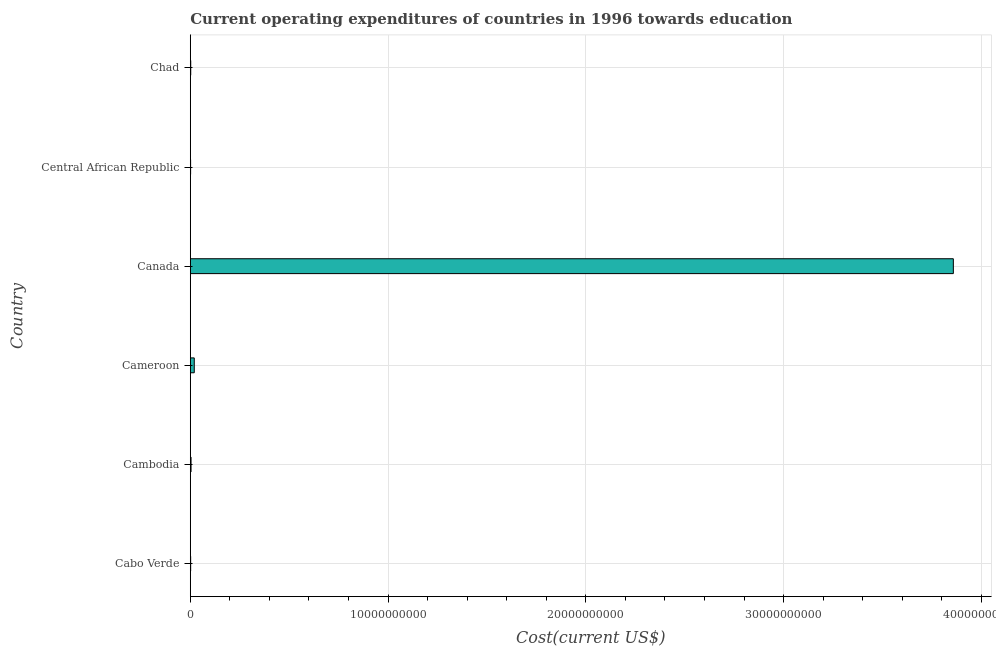What is the title of the graph?
Your answer should be compact. Current operating expenditures of countries in 1996 towards education. What is the label or title of the X-axis?
Keep it short and to the point. Cost(current US$). What is the label or title of the Y-axis?
Offer a terse response. Country. What is the education expenditure in Cameroon?
Make the answer very short. 2.01e+08. Across all countries, what is the maximum education expenditure?
Provide a succinct answer. 3.86e+1. Across all countries, what is the minimum education expenditure?
Give a very brief answer. 1.58e+07. In which country was the education expenditure maximum?
Provide a short and direct response. Canada. In which country was the education expenditure minimum?
Make the answer very short. Central African Republic. What is the sum of the education expenditure?
Give a very brief answer. 3.89e+1. What is the difference between the education expenditure in Cabo Verde and Central African Republic?
Your answer should be compact. 2.34e+06. What is the average education expenditure per country?
Your answer should be compact. 6.48e+09. What is the median education expenditure?
Ensure brevity in your answer.  3.03e+07. In how many countries, is the education expenditure greater than 20000000000 US$?
Your answer should be very brief. 1. What is the ratio of the education expenditure in Cambodia to that in Central African Republic?
Your answer should be compact. 2.42. Is the education expenditure in Cabo Verde less than that in Central African Republic?
Give a very brief answer. No. Is the difference between the education expenditure in Cambodia and Canada greater than the difference between any two countries?
Your answer should be very brief. No. What is the difference between the highest and the second highest education expenditure?
Provide a short and direct response. 3.84e+1. What is the difference between the highest and the lowest education expenditure?
Give a very brief answer. 3.86e+1. In how many countries, is the education expenditure greater than the average education expenditure taken over all countries?
Offer a very short reply. 1. How many countries are there in the graph?
Offer a terse response. 6. What is the Cost(current US$) in Cabo Verde?
Provide a short and direct response. 1.81e+07. What is the Cost(current US$) of Cambodia?
Give a very brief answer. 3.81e+07. What is the Cost(current US$) in Cameroon?
Your response must be concise. 2.01e+08. What is the Cost(current US$) of Canada?
Offer a terse response. 3.86e+1. What is the Cost(current US$) in Central African Republic?
Make the answer very short. 1.58e+07. What is the Cost(current US$) in Chad?
Make the answer very short. 2.24e+07. What is the difference between the Cost(current US$) in Cabo Verde and Cambodia?
Make the answer very short. -2.00e+07. What is the difference between the Cost(current US$) in Cabo Verde and Cameroon?
Make the answer very short. -1.83e+08. What is the difference between the Cost(current US$) in Cabo Verde and Canada?
Offer a very short reply. -3.86e+1. What is the difference between the Cost(current US$) in Cabo Verde and Central African Republic?
Make the answer very short. 2.34e+06. What is the difference between the Cost(current US$) in Cabo Verde and Chad?
Make the answer very short. -4.23e+06. What is the difference between the Cost(current US$) in Cambodia and Cameroon?
Give a very brief answer. -1.63e+08. What is the difference between the Cost(current US$) in Cambodia and Canada?
Offer a terse response. -3.85e+1. What is the difference between the Cost(current US$) in Cambodia and Central African Republic?
Provide a succinct answer. 2.24e+07. What is the difference between the Cost(current US$) in Cambodia and Chad?
Make the answer very short. 1.58e+07. What is the difference between the Cost(current US$) in Cameroon and Canada?
Make the answer very short. -3.84e+1. What is the difference between the Cost(current US$) in Cameroon and Central African Republic?
Provide a succinct answer. 1.85e+08. What is the difference between the Cost(current US$) in Cameroon and Chad?
Provide a succinct answer. 1.79e+08. What is the difference between the Cost(current US$) in Canada and Central African Republic?
Provide a short and direct response. 3.86e+1. What is the difference between the Cost(current US$) in Canada and Chad?
Make the answer very short. 3.86e+1. What is the difference between the Cost(current US$) in Central African Republic and Chad?
Your response must be concise. -6.57e+06. What is the ratio of the Cost(current US$) in Cabo Verde to that in Cambodia?
Your response must be concise. 0.47. What is the ratio of the Cost(current US$) in Cabo Verde to that in Cameroon?
Your answer should be compact. 0.09. What is the ratio of the Cost(current US$) in Cabo Verde to that in Canada?
Provide a short and direct response. 0. What is the ratio of the Cost(current US$) in Cabo Verde to that in Central African Republic?
Offer a terse response. 1.15. What is the ratio of the Cost(current US$) in Cabo Verde to that in Chad?
Provide a short and direct response. 0.81. What is the ratio of the Cost(current US$) in Cambodia to that in Cameroon?
Provide a succinct answer. 0.19. What is the ratio of the Cost(current US$) in Cambodia to that in Canada?
Your answer should be compact. 0. What is the ratio of the Cost(current US$) in Cambodia to that in Central African Republic?
Your answer should be compact. 2.42. What is the ratio of the Cost(current US$) in Cambodia to that in Chad?
Provide a short and direct response. 1.71. What is the ratio of the Cost(current US$) in Cameroon to that in Canada?
Make the answer very short. 0.01. What is the ratio of the Cost(current US$) in Cameroon to that in Central African Republic?
Keep it short and to the point. 12.74. What is the ratio of the Cost(current US$) in Cameroon to that in Chad?
Provide a short and direct response. 8.99. What is the ratio of the Cost(current US$) in Canada to that in Central African Republic?
Your answer should be compact. 2443.84. What is the ratio of the Cost(current US$) in Canada to that in Chad?
Make the answer very short. 1725.49. What is the ratio of the Cost(current US$) in Central African Republic to that in Chad?
Give a very brief answer. 0.71. 